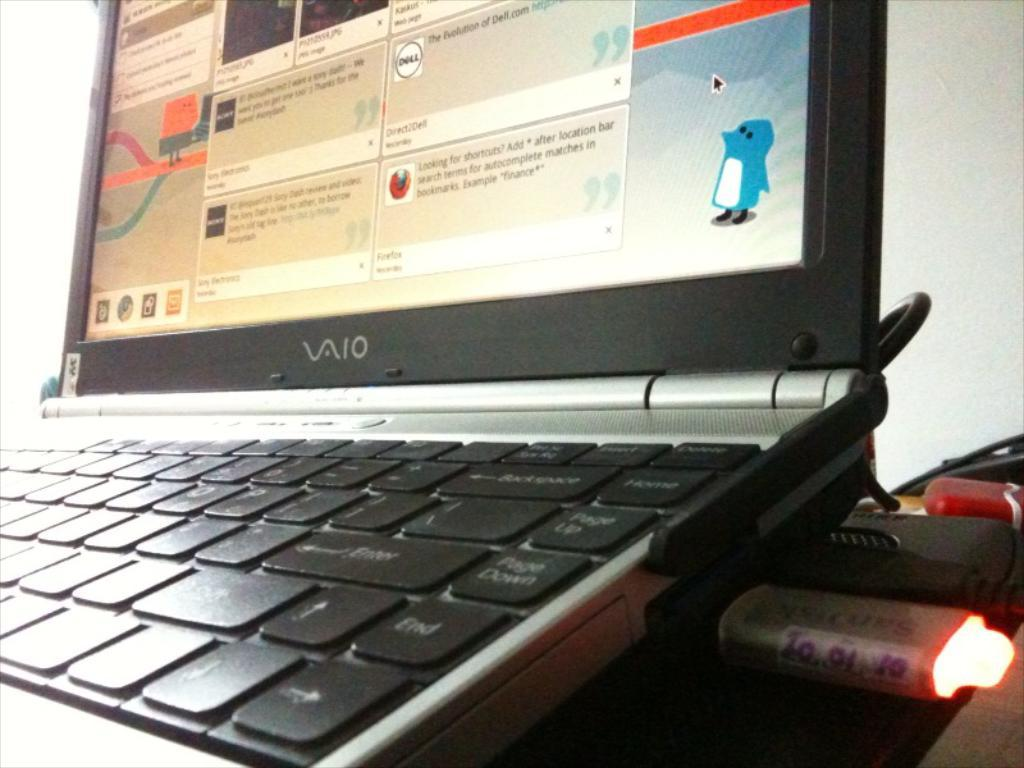<image>
Share a concise interpretation of the image provided. Vaio laptop with at least one program open on screen. 